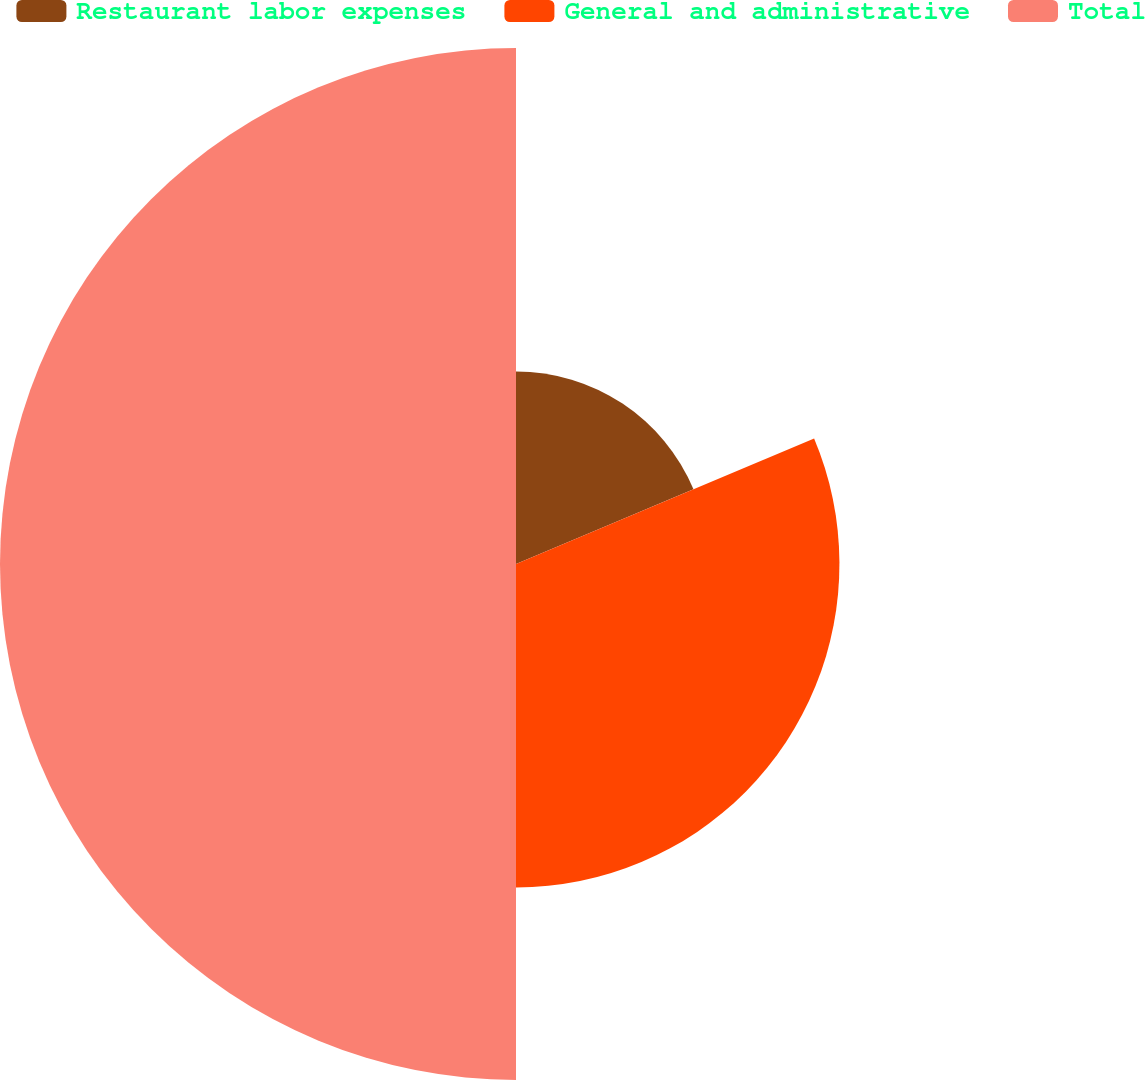<chart> <loc_0><loc_0><loc_500><loc_500><pie_chart><fcel>Restaurant labor expenses<fcel>General and administrative<fcel>Total<nl><fcel>18.66%<fcel>31.34%<fcel>50.0%<nl></chart> 